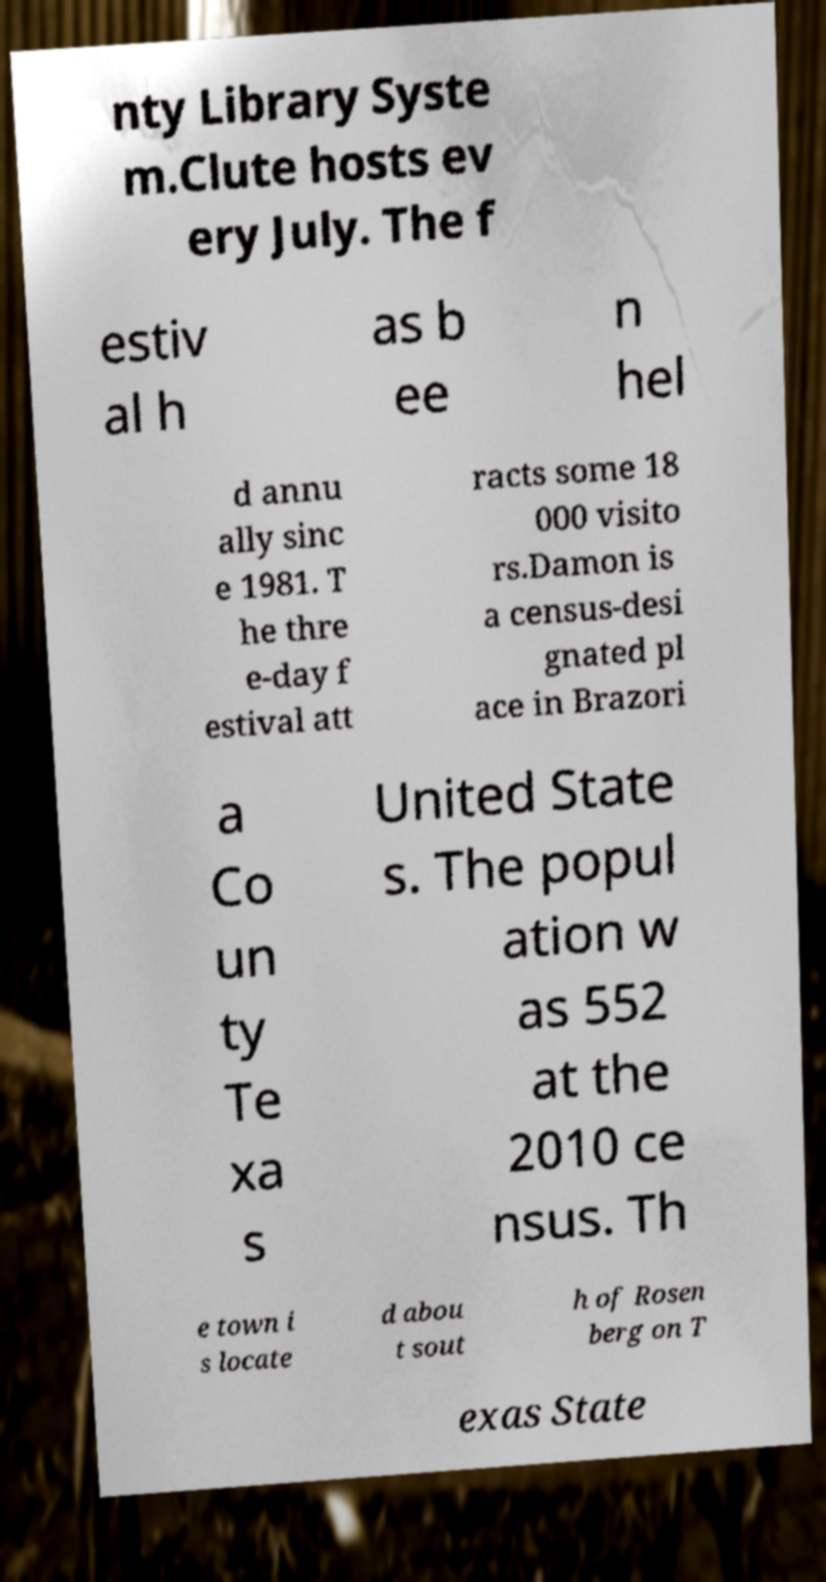Can you accurately transcribe the text from the provided image for me? nty Library Syste m.Clute hosts ev ery July. The f estiv al h as b ee n hel d annu ally sinc e 1981. T he thre e-day f estival att racts some 18 000 visito rs.Damon is a census-desi gnated pl ace in Brazori a Co un ty Te xa s United State s. The popul ation w as 552 at the 2010 ce nsus. Th e town i s locate d abou t sout h of Rosen berg on T exas State 